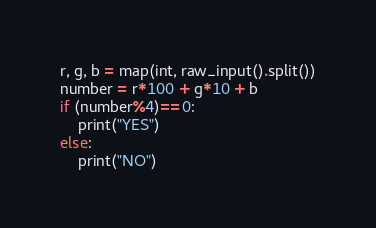<code> <loc_0><loc_0><loc_500><loc_500><_Python_>r, g, b = map(int, raw_input().split())
number = r*100 + g*10 + b
if (number%4)==0:
    print("YES")
else:
    print("NO")</code> 